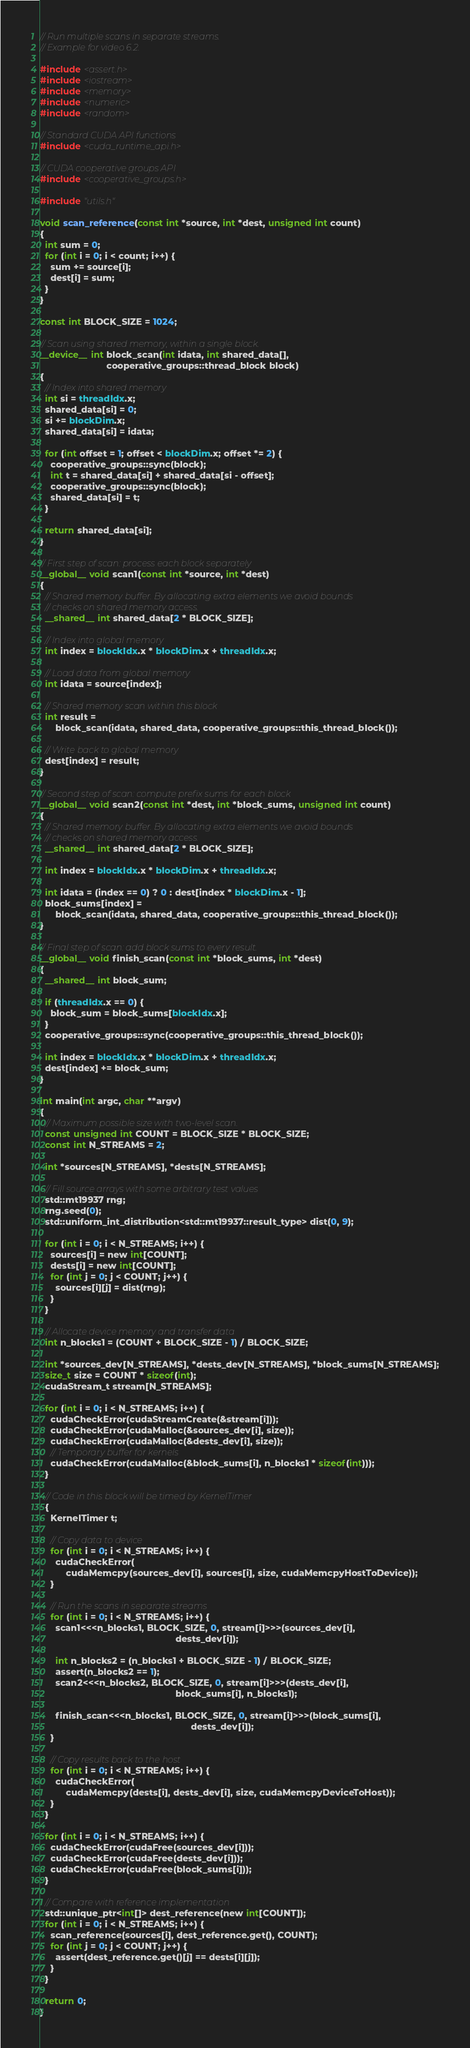Convert code to text. <code><loc_0><loc_0><loc_500><loc_500><_Cuda_>// Run multiple scans in separate streams.
// Example for video 6.2.

#include <assert.h>
#include <iostream>
#include <memory>
#include <numeric>
#include <random>

// Standard CUDA API functions
#include <cuda_runtime_api.h>

// CUDA cooperative groups API
#include <cooperative_groups.h>

#include "utils.h"

void scan_reference(const int *source, int *dest, unsigned int count)
{
  int sum = 0;
  for (int i = 0; i < count; i++) {
    sum += source[i];
    dest[i] = sum;
  }
}

const int BLOCK_SIZE = 1024;

// Scan using shared memory, within a single block.
__device__ int block_scan(int idata, int shared_data[],
                          cooperative_groups::thread_block block)
{
  // Index into shared memory
  int si = threadIdx.x;
  shared_data[si] = 0;
  si += blockDim.x;
  shared_data[si] = idata;

  for (int offset = 1; offset < blockDim.x; offset *= 2) {
    cooperative_groups::sync(block);
    int t = shared_data[si] + shared_data[si - offset];
    cooperative_groups::sync(block);
    shared_data[si] = t;
  }

  return shared_data[si];
}

// First step of scan: process each block separately
__global__ void scan1(const int *source, int *dest)
{
  // Shared memory buffer. By allocating extra elements we avoid bounds
  // checks on shared memory access.
  __shared__ int shared_data[2 * BLOCK_SIZE];

  // Index into global memory
  int index = blockIdx.x * blockDim.x + threadIdx.x;

  // Load data from global memory
  int idata = source[index];

  // Shared memory scan within this block
  int result =
      block_scan(idata, shared_data, cooperative_groups::this_thread_block());

  // Write back to global memory
  dest[index] = result;
}

// Second step of scan: compute prefix sums for each block
__global__ void scan2(const int *dest, int *block_sums, unsigned int count)
{
  // Shared memory buffer. By allocating extra elements we avoid bounds
  // checks on shared memory access.
  __shared__ int shared_data[2 * BLOCK_SIZE];

  int index = blockIdx.x * blockDim.x + threadIdx.x;

  int idata = (index == 0) ? 0 : dest[index * blockDim.x - 1];
  block_sums[index] =
      block_scan(idata, shared_data, cooperative_groups::this_thread_block());
}

// Final step of scan: add block sums to every result.
__global__ void finish_scan(const int *block_sums, int *dest)
{
  __shared__ int block_sum;

  if (threadIdx.x == 0) {
    block_sum = block_sums[blockIdx.x];
  }
  cooperative_groups::sync(cooperative_groups::this_thread_block());

  int index = blockIdx.x * blockDim.x + threadIdx.x;
  dest[index] += block_sum;
}

int main(int argc, char **argv)
{
  // Maximum possible size with two-level scan.
  const unsigned int COUNT = BLOCK_SIZE * BLOCK_SIZE;
  const int N_STREAMS = 2;

  int *sources[N_STREAMS], *dests[N_STREAMS];

  // Fill source arrays with some arbitrary test values
  std::mt19937 rng;
  rng.seed(0);
  std::uniform_int_distribution<std::mt19937::result_type> dist(0, 9);

  for (int i = 0; i < N_STREAMS; i++) {
    sources[i] = new int[COUNT];
    dests[i] = new int[COUNT];
    for (int j = 0; j < COUNT; j++) {
      sources[i][j] = dist(rng);
    }
  }

  // Allocate device memory and transfer data
  int n_blocks1 = (COUNT + BLOCK_SIZE - 1) / BLOCK_SIZE;

  int *sources_dev[N_STREAMS], *dests_dev[N_STREAMS], *block_sums[N_STREAMS];
  size_t size = COUNT * sizeof(int);
  cudaStream_t stream[N_STREAMS];

  for (int i = 0; i < N_STREAMS; i++) {
    cudaCheckError(cudaStreamCreate(&stream[i]));
    cudaCheckError(cudaMalloc(&sources_dev[i], size));
    cudaCheckError(cudaMalloc(&dests_dev[i], size));
    // Temporary buffer for kernels
    cudaCheckError(cudaMalloc(&block_sums[i], n_blocks1 * sizeof(int)));
  }

  // Code in this block will be timed by KernelTimer
  {
    KernelTimer t;

    // Copy data to device
    for (int i = 0; i < N_STREAMS; i++) {
      cudaCheckError(
          cudaMemcpy(sources_dev[i], sources[i], size, cudaMemcpyHostToDevice));
    }

    // Run the scans in separate streams
    for (int i = 0; i < N_STREAMS; i++) {
      scan1<<<n_blocks1, BLOCK_SIZE, 0, stream[i]>>>(sources_dev[i],
                                                     dests_dev[i]);

      int n_blocks2 = (n_blocks1 + BLOCK_SIZE - 1) / BLOCK_SIZE;
      assert(n_blocks2 == 1);
      scan2<<<n_blocks2, BLOCK_SIZE, 0, stream[i]>>>(dests_dev[i],
                                                     block_sums[i], n_blocks1);

      finish_scan<<<n_blocks1, BLOCK_SIZE, 0, stream[i]>>>(block_sums[i],
                                                           dests_dev[i]);
    }

    // Copy results back to the host
    for (int i = 0; i < N_STREAMS; i++) {
      cudaCheckError(
          cudaMemcpy(dests[i], dests_dev[i], size, cudaMemcpyDeviceToHost));
    }
  }

  for (int i = 0; i < N_STREAMS; i++) {
    cudaCheckError(cudaFree(sources_dev[i]));
    cudaCheckError(cudaFree(dests_dev[i]));
    cudaCheckError(cudaFree(block_sums[i]));
  }

  // Compare with reference implementation
  std::unique_ptr<int[]> dest_reference(new int[COUNT]);
  for (int i = 0; i < N_STREAMS; i++) {
    scan_reference(sources[i], dest_reference.get(), COUNT);
    for (int j = 0; j < COUNT; j++) {
      assert(dest_reference.get()[j] == dests[i][j]);
    }
  }

  return 0;
}
</code> 